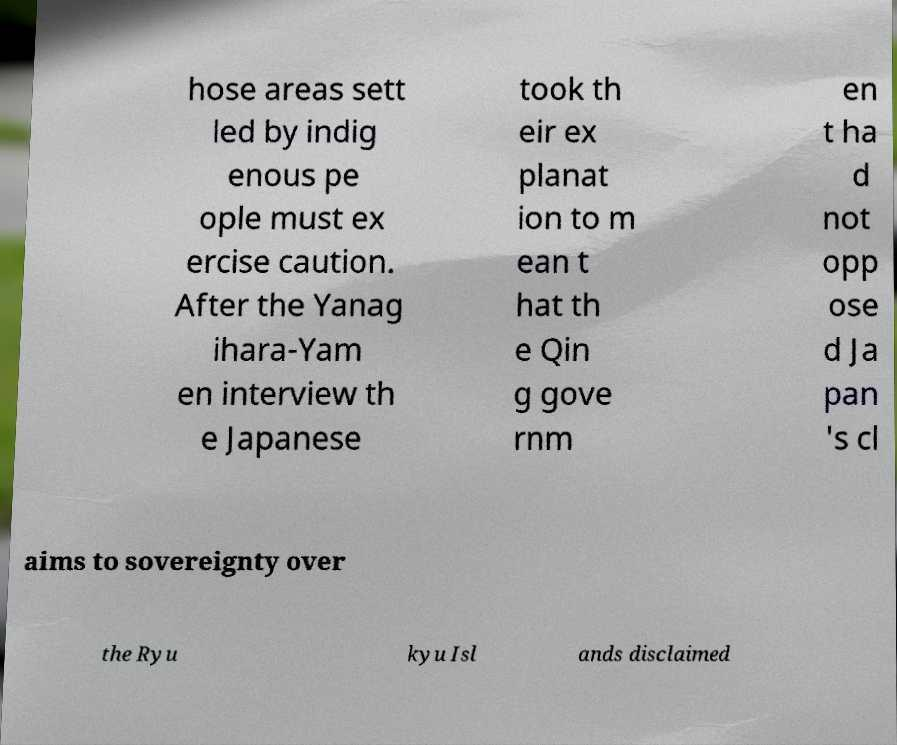Can you read and provide the text displayed in the image?This photo seems to have some interesting text. Can you extract and type it out for me? hose areas sett led by indig enous pe ople must ex ercise caution. After the Yanag ihara-Yam en interview th e Japanese took th eir ex planat ion to m ean t hat th e Qin g gove rnm en t ha d not opp ose d Ja pan 's cl aims to sovereignty over the Ryu kyu Isl ands disclaimed 